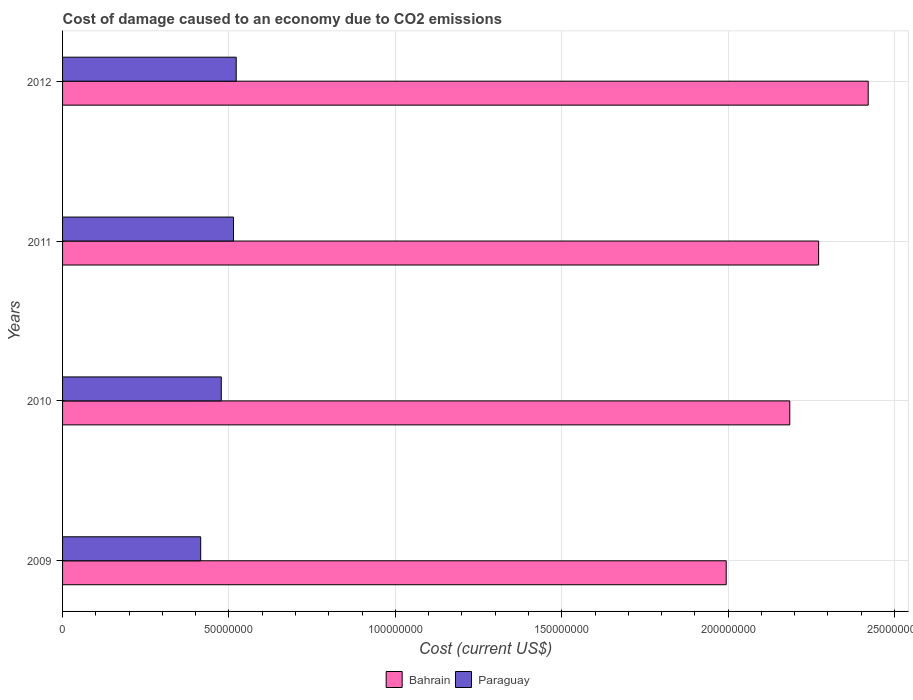How many different coloured bars are there?
Offer a very short reply. 2. How many groups of bars are there?
Ensure brevity in your answer.  4. How many bars are there on the 4th tick from the top?
Make the answer very short. 2. What is the label of the 2nd group of bars from the top?
Provide a short and direct response. 2011. What is the cost of damage caused due to CO2 emissisons in Bahrain in 2011?
Offer a terse response. 2.27e+08. Across all years, what is the maximum cost of damage caused due to CO2 emissisons in Paraguay?
Make the answer very short. 5.22e+07. Across all years, what is the minimum cost of damage caused due to CO2 emissisons in Bahrain?
Your answer should be compact. 1.99e+08. In which year was the cost of damage caused due to CO2 emissisons in Paraguay maximum?
Ensure brevity in your answer.  2012. What is the total cost of damage caused due to CO2 emissisons in Bahrain in the graph?
Your answer should be very brief. 8.87e+08. What is the difference between the cost of damage caused due to CO2 emissisons in Bahrain in 2009 and that in 2010?
Ensure brevity in your answer.  -1.91e+07. What is the difference between the cost of damage caused due to CO2 emissisons in Paraguay in 2010 and the cost of damage caused due to CO2 emissisons in Bahrain in 2012?
Keep it short and to the point. -1.94e+08. What is the average cost of damage caused due to CO2 emissisons in Bahrain per year?
Provide a succinct answer. 2.22e+08. In the year 2009, what is the difference between the cost of damage caused due to CO2 emissisons in Paraguay and cost of damage caused due to CO2 emissisons in Bahrain?
Make the answer very short. -1.58e+08. In how many years, is the cost of damage caused due to CO2 emissisons in Bahrain greater than 20000000 US$?
Your response must be concise. 4. What is the ratio of the cost of damage caused due to CO2 emissisons in Bahrain in 2009 to that in 2010?
Your response must be concise. 0.91. What is the difference between the highest and the second highest cost of damage caused due to CO2 emissisons in Bahrain?
Your response must be concise. 1.49e+07. What is the difference between the highest and the lowest cost of damage caused due to CO2 emissisons in Bahrain?
Ensure brevity in your answer.  4.27e+07. In how many years, is the cost of damage caused due to CO2 emissisons in Paraguay greater than the average cost of damage caused due to CO2 emissisons in Paraguay taken over all years?
Make the answer very short. 2. What does the 1st bar from the top in 2010 represents?
Offer a terse response. Paraguay. What does the 1st bar from the bottom in 2010 represents?
Your answer should be very brief. Bahrain. Are all the bars in the graph horizontal?
Offer a very short reply. Yes. How many years are there in the graph?
Provide a short and direct response. 4. What is the difference between two consecutive major ticks on the X-axis?
Your answer should be very brief. 5.00e+07. Are the values on the major ticks of X-axis written in scientific E-notation?
Make the answer very short. No. Does the graph contain any zero values?
Your answer should be very brief. No. Where does the legend appear in the graph?
Keep it short and to the point. Bottom center. What is the title of the graph?
Your answer should be very brief. Cost of damage caused to an economy due to CO2 emissions. Does "Azerbaijan" appear as one of the legend labels in the graph?
Provide a succinct answer. No. What is the label or title of the X-axis?
Provide a succinct answer. Cost (current US$). What is the Cost (current US$) of Bahrain in 2009?
Your answer should be compact. 1.99e+08. What is the Cost (current US$) in Paraguay in 2009?
Provide a succinct answer. 4.15e+07. What is the Cost (current US$) in Bahrain in 2010?
Your answer should be compact. 2.19e+08. What is the Cost (current US$) in Paraguay in 2010?
Ensure brevity in your answer.  4.77e+07. What is the Cost (current US$) in Bahrain in 2011?
Keep it short and to the point. 2.27e+08. What is the Cost (current US$) of Paraguay in 2011?
Your answer should be very brief. 5.14e+07. What is the Cost (current US$) in Bahrain in 2012?
Keep it short and to the point. 2.42e+08. What is the Cost (current US$) in Paraguay in 2012?
Your answer should be very brief. 5.22e+07. Across all years, what is the maximum Cost (current US$) of Bahrain?
Offer a terse response. 2.42e+08. Across all years, what is the maximum Cost (current US$) in Paraguay?
Offer a very short reply. 5.22e+07. Across all years, what is the minimum Cost (current US$) of Bahrain?
Your answer should be compact. 1.99e+08. Across all years, what is the minimum Cost (current US$) in Paraguay?
Your answer should be compact. 4.15e+07. What is the total Cost (current US$) of Bahrain in the graph?
Offer a terse response. 8.87e+08. What is the total Cost (current US$) in Paraguay in the graph?
Keep it short and to the point. 1.93e+08. What is the difference between the Cost (current US$) in Bahrain in 2009 and that in 2010?
Make the answer very short. -1.91e+07. What is the difference between the Cost (current US$) of Paraguay in 2009 and that in 2010?
Make the answer very short. -6.19e+06. What is the difference between the Cost (current US$) of Bahrain in 2009 and that in 2011?
Provide a succinct answer. -2.78e+07. What is the difference between the Cost (current US$) of Paraguay in 2009 and that in 2011?
Ensure brevity in your answer.  -9.85e+06. What is the difference between the Cost (current US$) in Bahrain in 2009 and that in 2012?
Offer a terse response. -4.27e+07. What is the difference between the Cost (current US$) in Paraguay in 2009 and that in 2012?
Your answer should be very brief. -1.07e+07. What is the difference between the Cost (current US$) in Bahrain in 2010 and that in 2011?
Offer a very short reply. -8.67e+06. What is the difference between the Cost (current US$) in Paraguay in 2010 and that in 2011?
Provide a short and direct response. -3.66e+06. What is the difference between the Cost (current US$) of Bahrain in 2010 and that in 2012?
Your response must be concise. -2.36e+07. What is the difference between the Cost (current US$) in Paraguay in 2010 and that in 2012?
Your answer should be very brief. -4.48e+06. What is the difference between the Cost (current US$) in Bahrain in 2011 and that in 2012?
Your answer should be very brief. -1.49e+07. What is the difference between the Cost (current US$) of Paraguay in 2011 and that in 2012?
Offer a very short reply. -8.17e+05. What is the difference between the Cost (current US$) in Bahrain in 2009 and the Cost (current US$) in Paraguay in 2010?
Give a very brief answer. 1.52e+08. What is the difference between the Cost (current US$) in Bahrain in 2009 and the Cost (current US$) in Paraguay in 2011?
Your response must be concise. 1.48e+08. What is the difference between the Cost (current US$) in Bahrain in 2009 and the Cost (current US$) in Paraguay in 2012?
Provide a short and direct response. 1.47e+08. What is the difference between the Cost (current US$) of Bahrain in 2010 and the Cost (current US$) of Paraguay in 2011?
Offer a terse response. 1.67e+08. What is the difference between the Cost (current US$) in Bahrain in 2010 and the Cost (current US$) in Paraguay in 2012?
Your answer should be compact. 1.66e+08. What is the difference between the Cost (current US$) of Bahrain in 2011 and the Cost (current US$) of Paraguay in 2012?
Your answer should be very brief. 1.75e+08. What is the average Cost (current US$) of Bahrain per year?
Ensure brevity in your answer.  2.22e+08. What is the average Cost (current US$) of Paraguay per year?
Make the answer very short. 4.82e+07. In the year 2009, what is the difference between the Cost (current US$) of Bahrain and Cost (current US$) of Paraguay?
Your answer should be very brief. 1.58e+08. In the year 2010, what is the difference between the Cost (current US$) in Bahrain and Cost (current US$) in Paraguay?
Your answer should be compact. 1.71e+08. In the year 2011, what is the difference between the Cost (current US$) of Bahrain and Cost (current US$) of Paraguay?
Ensure brevity in your answer.  1.76e+08. In the year 2012, what is the difference between the Cost (current US$) of Bahrain and Cost (current US$) of Paraguay?
Offer a very short reply. 1.90e+08. What is the ratio of the Cost (current US$) in Bahrain in 2009 to that in 2010?
Offer a terse response. 0.91. What is the ratio of the Cost (current US$) of Paraguay in 2009 to that in 2010?
Keep it short and to the point. 0.87. What is the ratio of the Cost (current US$) in Bahrain in 2009 to that in 2011?
Your response must be concise. 0.88. What is the ratio of the Cost (current US$) of Paraguay in 2009 to that in 2011?
Give a very brief answer. 0.81. What is the ratio of the Cost (current US$) of Bahrain in 2009 to that in 2012?
Give a very brief answer. 0.82. What is the ratio of the Cost (current US$) in Paraguay in 2009 to that in 2012?
Offer a very short reply. 0.8. What is the ratio of the Cost (current US$) of Bahrain in 2010 to that in 2011?
Your response must be concise. 0.96. What is the ratio of the Cost (current US$) of Paraguay in 2010 to that in 2011?
Your answer should be very brief. 0.93. What is the ratio of the Cost (current US$) of Bahrain in 2010 to that in 2012?
Offer a terse response. 0.9. What is the ratio of the Cost (current US$) of Paraguay in 2010 to that in 2012?
Keep it short and to the point. 0.91. What is the ratio of the Cost (current US$) in Bahrain in 2011 to that in 2012?
Give a very brief answer. 0.94. What is the ratio of the Cost (current US$) in Paraguay in 2011 to that in 2012?
Your response must be concise. 0.98. What is the difference between the highest and the second highest Cost (current US$) in Bahrain?
Ensure brevity in your answer.  1.49e+07. What is the difference between the highest and the second highest Cost (current US$) in Paraguay?
Provide a short and direct response. 8.17e+05. What is the difference between the highest and the lowest Cost (current US$) in Bahrain?
Provide a succinct answer. 4.27e+07. What is the difference between the highest and the lowest Cost (current US$) in Paraguay?
Ensure brevity in your answer.  1.07e+07. 